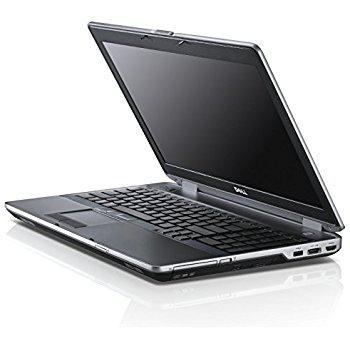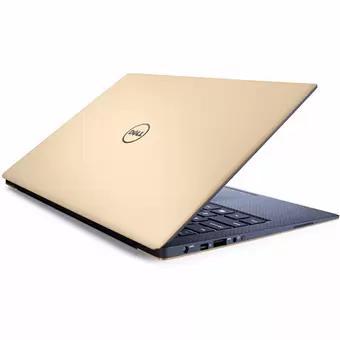The first image is the image on the left, the second image is the image on the right. For the images shown, is this caption "The computers are sitting back to back." true? Answer yes or no. Yes. The first image is the image on the left, the second image is the image on the right. For the images displayed, is the sentence "At least one image shows a partly open laptop with the screen and keyboard forming less than a 90-degree angle." factually correct? Answer yes or no. Yes. 